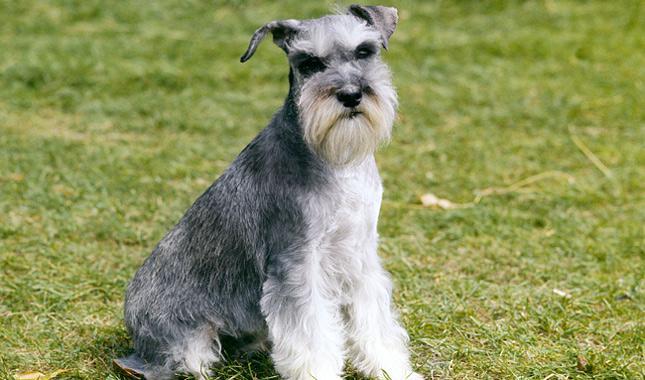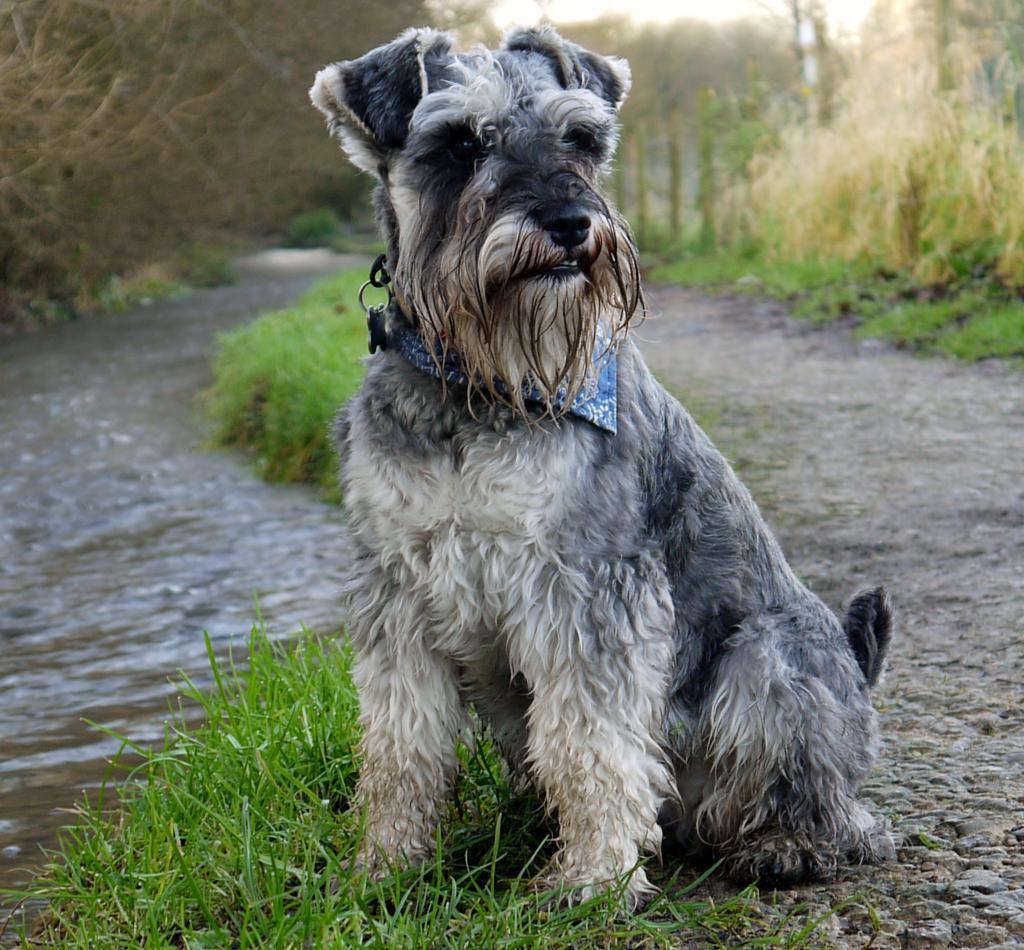The first image is the image on the left, the second image is the image on the right. Considering the images on both sides, is "At least one dog has no visible collar on." valid? Answer yes or no. Yes. The first image is the image on the left, the second image is the image on the right. Considering the images on both sides, is "The dog in the right image is sitting on grass looking towards the right." valid? Answer yes or no. Yes. The first image is the image on the left, the second image is the image on the right. Evaluate the accuracy of this statement regarding the images: "At least one of the dogs is not outside.". Is it true? Answer yes or no. No. 